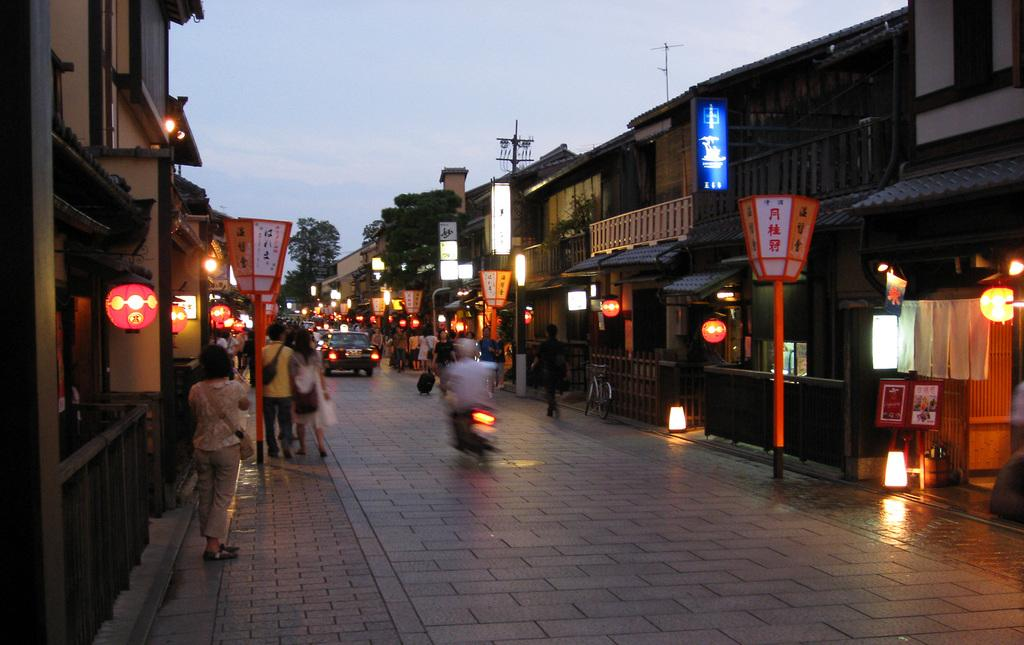What is the main feature of the image? There is a way or road in the image. What is happening on the road? There are vehicles on the road. Are there any people in the image? Yes, there are people on either side of the road. What can be seen on either side of the road besides the people? There are buildings on either side of the road. What is visible in the background of the image? Trees are visible in the background of the image. Can you tell me how many goose feathers are on the sack in the image? There is no sack or goose feathers present in the image. What type of picture is hanging on the wall in the image? There is no picture hanging on the wall in the image. 